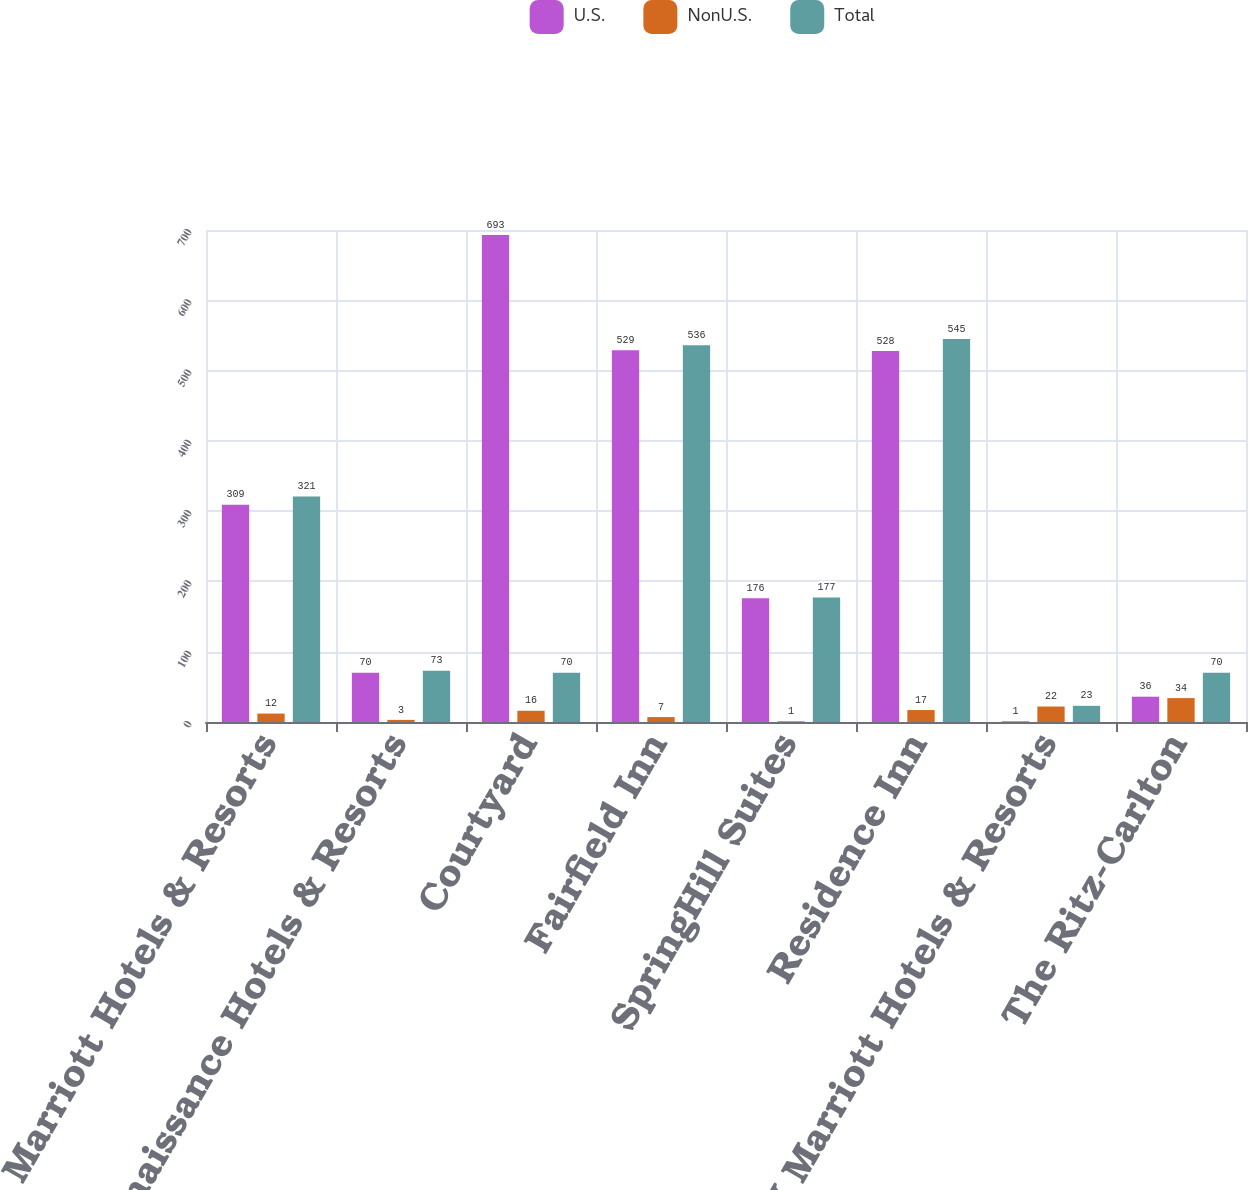Convert chart to OTSL. <chart><loc_0><loc_0><loc_500><loc_500><stacked_bar_chart><ecel><fcel>Marriott Hotels & Resorts<fcel>Renaissance Hotels & Resorts<fcel>Courtyard<fcel>Fairfield Inn<fcel>SpringHill Suites<fcel>Residence Inn<fcel>JW Marriott Hotels & Resorts<fcel>The Ritz-Carlton<nl><fcel>U.S.<fcel>309<fcel>70<fcel>693<fcel>529<fcel>176<fcel>528<fcel>1<fcel>36<nl><fcel>NonU.S.<fcel>12<fcel>3<fcel>16<fcel>7<fcel>1<fcel>17<fcel>22<fcel>34<nl><fcel>Total<fcel>321<fcel>73<fcel>70<fcel>536<fcel>177<fcel>545<fcel>23<fcel>70<nl></chart> 